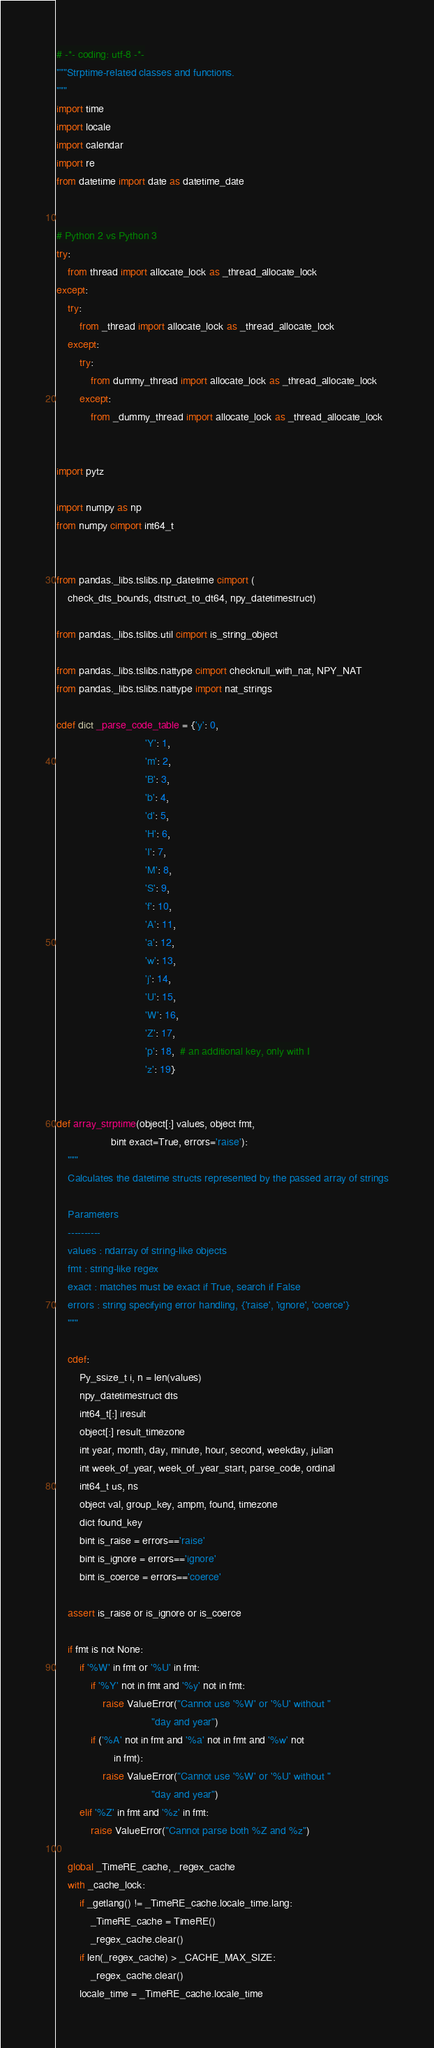Convert code to text. <code><loc_0><loc_0><loc_500><loc_500><_Cython_># -*- coding: utf-8 -*-
"""Strptime-related classes and functions.
"""
import time
import locale
import calendar
import re
from datetime import date as datetime_date


# Python 2 vs Python 3
try:
    from thread import allocate_lock as _thread_allocate_lock
except:
    try:
        from _thread import allocate_lock as _thread_allocate_lock
    except:
        try:
            from dummy_thread import allocate_lock as _thread_allocate_lock
        except:
            from _dummy_thread import allocate_lock as _thread_allocate_lock


import pytz

import numpy as np
from numpy cimport int64_t


from pandas._libs.tslibs.np_datetime cimport (
    check_dts_bounds, dtstruct_to_dt64, npy_datetimestruct)

from pandas._libs.tslibs.util cimport is_string_object

from pandas._libs.tslibs.nattype cimport checknull_with_nat, NPY_NAT
from pandas._libs.tslibs.nattype import nat_strings

cdef dict _parse_code_table = {'y': 0,
                               'Y': 1,
                               'm': 2,
                               'B': 3,
                               'b': 4,
                               'd': 5,
                               'H': 6,
                               'I': 7,
                               'M': 8,
                               'S': 9,
                               'f': 10,
                               'A': 11,
                               'a': 12,
                               'w': 13,
                               'j': 14,
                               'U': 15,
                               'W': 16,
                               'Z': 17,
                               'p': 18,  # an additional key, only with I
                               'z': 19}


def array_strptime(object[:] values, object fmt,
                   bint exact=True, errors='raise'):
    """
    Calculates the datetime structs represented by the passed array of strings

    Parameters
    ----------
    values : ndarray of string-like objects
    fmt : string-like regex
    exact : matches must be exact if True, search if False
    errors : string specifying error handling, {'raise', 'ignore', 'coerce'}
    """

    cdef:
        Py_ssize_t i, n = len(values)
        npy_datetimestruct dts
        int64_t[:] iresult
        object[:] result_timezone
        int year, month, day, minute, hour, second, weekday, julian
        int week_of_year, week_of_year_start, parse_code, ordinal
        int64_t us, ns
        object val, group_key, ampm, found, timezone
        dict found_key
        bint is_raise = errors=='raise'
        bint is_ignore = errors=='ignore'
        bint is_coerce = errors=='coerce'

    assert is_raise or is_ignore or is_coerce

    if fmt is not None:
        if '%W' in fmt or '%U' in fmt:
            if '%Y' not in fmt and '%y' not in fmt:
                raise ValueError("Cannot use '%W' or '%U' without "
                                 "day and year")
            if ('%A' not in fmt and '%a' not in fmt and '%w' not
                    in fmt):
                raise ValueError("Cannot use '%W' or '%U' without "
                                 "day and year")
        elif '%Z' in fmt and '%z' in fmt:
            raise ValueError("Cannot parse both %Z and %z")

    global _TimeRE_cache, _regex_cache
    with _cache_lock:
        if _getlang() != _TimeRE_cache.locale_time.lang:
            _TimeRE_cache = TimeRE()
            _regex_cache.clear()
        if len(_regex_cache) > _CACHE_MAX_SIZE:
            _regex_cache.clear()
        locale_time = _TimeRE_cache.locale_time</code> 